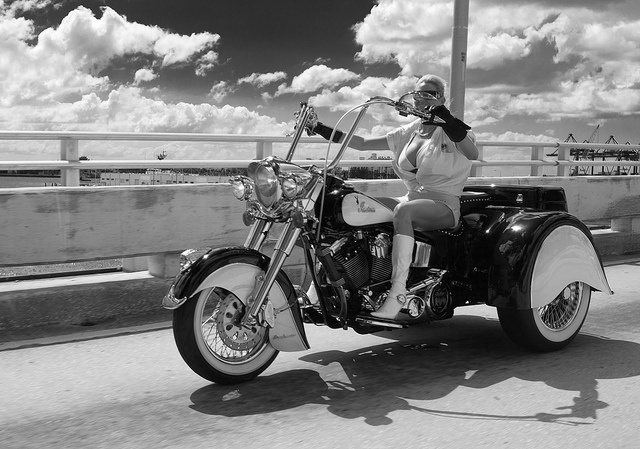Describe the objects in this image and their specific colors. I can see motorcycle in lightgray, black, darkgray, and gray tones and people in lightgray, gray, darkgray, and black tones in this image. 